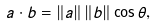<formula> <loc_0><loc_0><loc_500><loc_500>a \cdot b = \left \| a \right \| \left \| b \right \| \cos \theta ,</formula> 